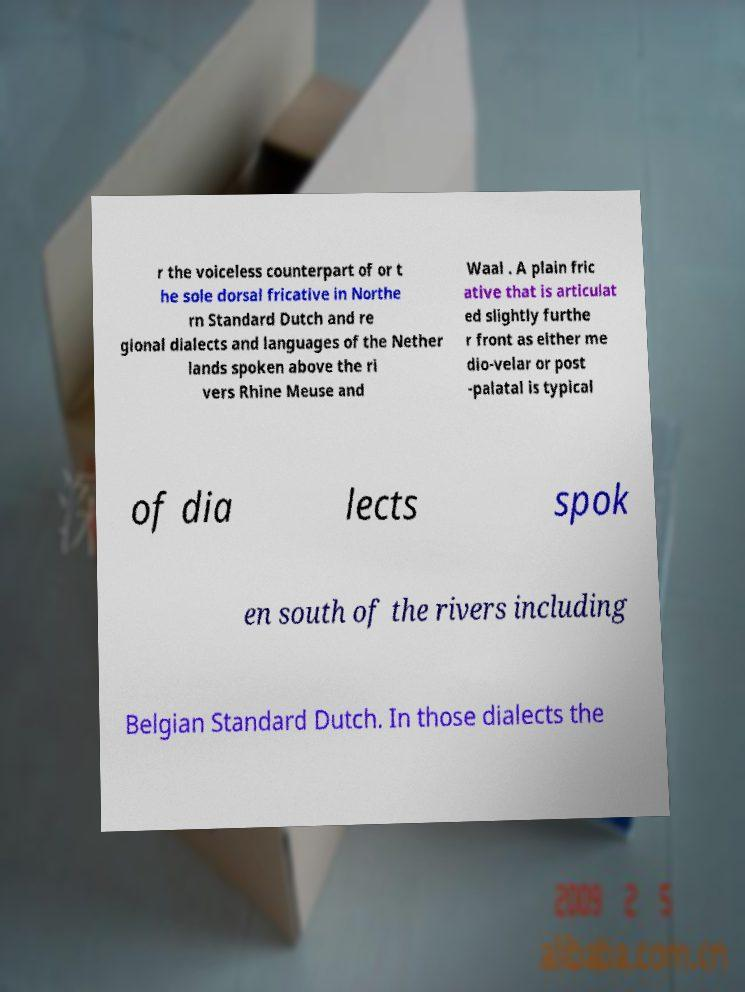There's text embedded in this image that I need extracted. Can you transcribe it verbatim? r the voiceless counterpart of or t he sole dorsal fricative in Northe rn Standard Dutch and re gional dialects and languages of the Nether lands spoken above the ri vers Rhine Meuse and Waal . A plain fric ative that is articulat ed slightly furthe r front as either me dio-velar or post -palatal is typical of dia lects spok en south of the rivers including Belgian Standard Dutch. In those dialects the 